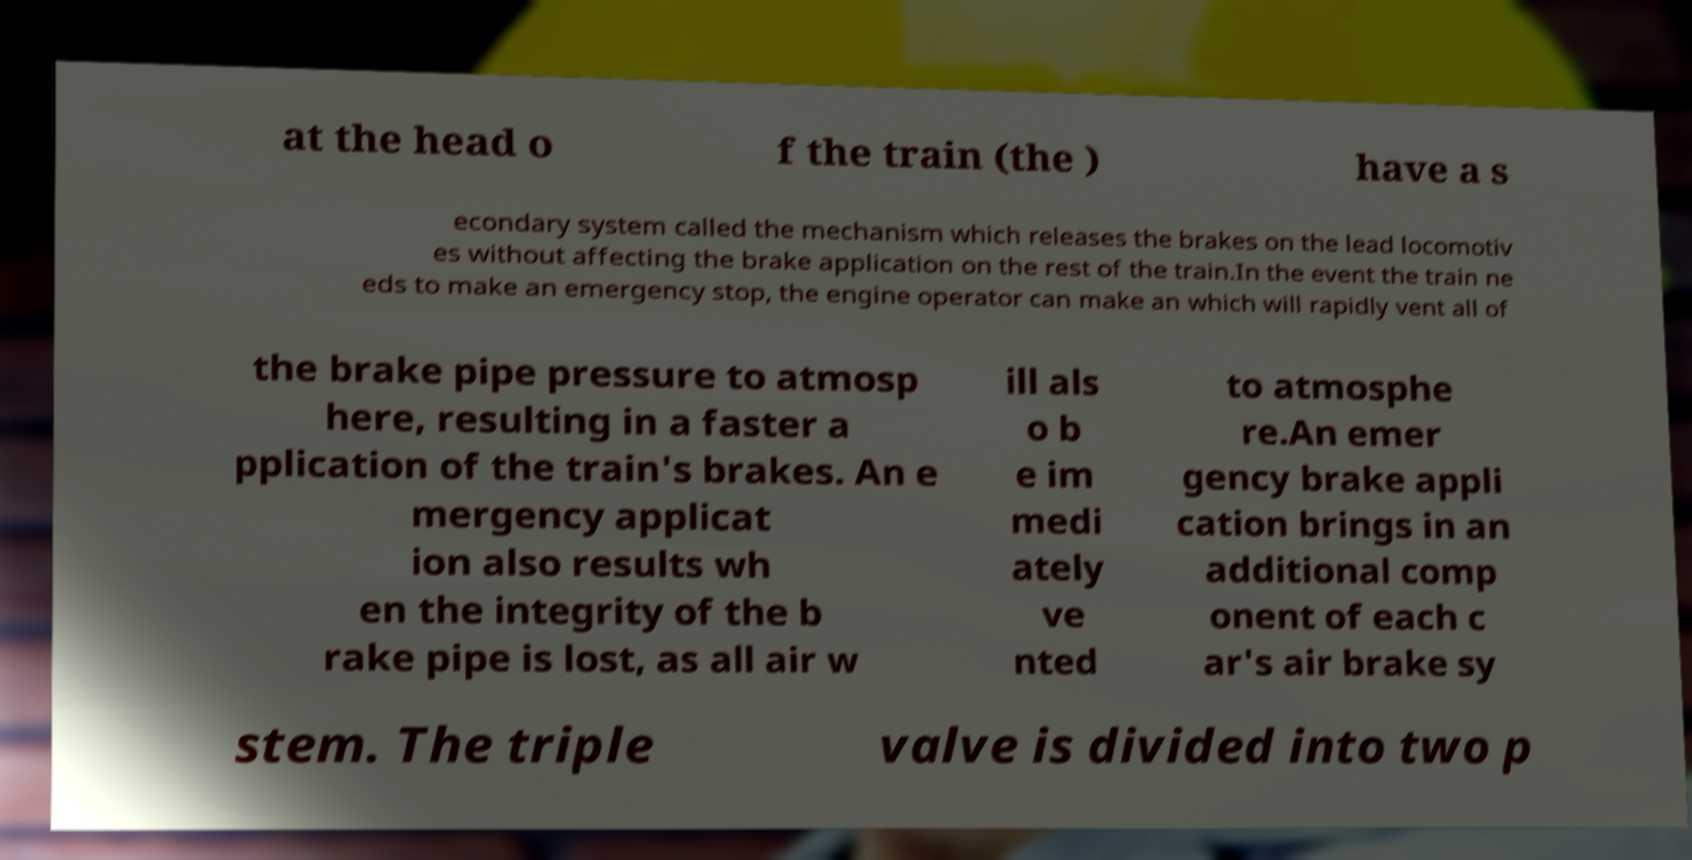Can you accurately transcribe the text from the provided image for me? at the head o f the train (the ) have a s econdary system called the mechanism which releases the brakes on the lead locomotiv es without affecting the brake application on the rest of the train.In the event the train ne eds to make an emergency stop, the engine operator can make an which will rapidly vent all of the brake pipe pressure to atmosp here, resulting in a faster a pplication of the train's brakes. An e mergency applicat ion also results wh en the integrity of the b rake pipe is lost, as all air w ill als o b e im medi ately ve nted to atmosphe re.An emer gency brake appli cation brings in an additional comp onent of each c ar's air brake sy stem. The triple valve is divided into two p 